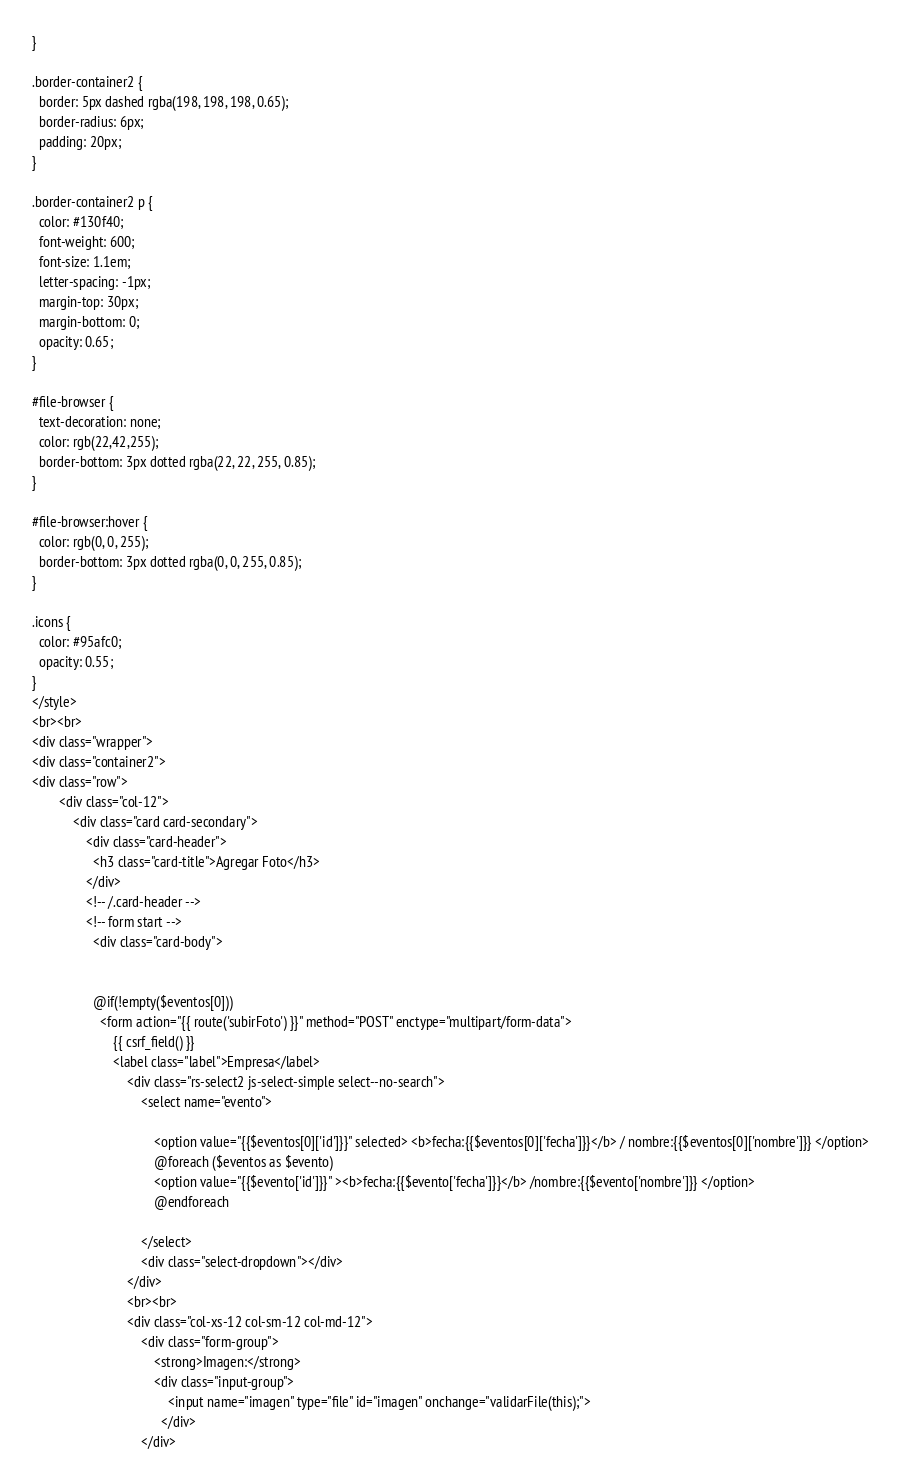<code> <loc_0><loc_0><loc_500><loc_500><_PHP_>}

.border-container2 {
  border: 5px dashed rgba(198, 198, 198, 0.65);
  border-radius: 6px;
  padding: 20px;
}

.border-container2 p {
  color: #130f40;
  font-weight: 600;
  font-size: 1.1em;
  letter-spacing: -1px;
  margin-top: 30px;
  margin-bottom: 0;
  opacity: 0.65;
}

#file-browser {
  text-decoration: none;
  color: rgb(22,42,255);
  border-bottom: 3px dotted rgba(22, 22, 255, 0.85);
}

#file-browser:hover {
  color: rgb(0, 0, 255);
  border-bottom: 3px dotted rgba(0, 0, 255, 0.85);
}

.icons {
  color: #95afc0;
  opacity: 0.55;
}
</style>
<br><br>
<div class="wrapper">
<div class="container2">
<div class="row">
        <div class="col-12">
            <div class="card card-secondary">
                <div class="card-header">
                  <h3 class="card-title">Agregar Foto</h3>
                </div>
                <!-- /.card-header -->
                <!-- form start -->
                  <div class="card-body">

                  
                  @if(!empty($eventos[0])) 
                    <form action="{{ route('subirFoto') }}" method="POST" enctype="multipart/form-data">
                        {{ csrf_field() }}
                        <label class="label">Empresa</label>
                            <div class="rs-select2 js-select-simple select--no-search">
                                <select name="evento">  
                                                                    
                                    <option value="{{$eventos[0]['id']}}" selected> <b>fecha:{{$eventos[0]['fecha']}}</b> / nombre:{{$eventos[0]['nombre']}} </option>
                                    @foreach ($eventos as $evento)
                                    <option value="{{$evento['id']}}" ><b>fecha:{{$evento['fecha']}}</b> /nombre:{{$evento['nombre']}} </option>
                                    @endforeach
                                  
                                </select>
                                <div class="select-dropdown"></div>
                            </div>
                            <br><br>
                            <div class="col-xs-12 col-sm-12 col-md-12">
                                <div class="form-group">
                                    <strong>Imagen:</strong>
                                    <div class="input-group">
                                        <input name="imagen" type="file" id="imagen" onchange="validarFile(this);">
                                      </div>
                                </div></code> 